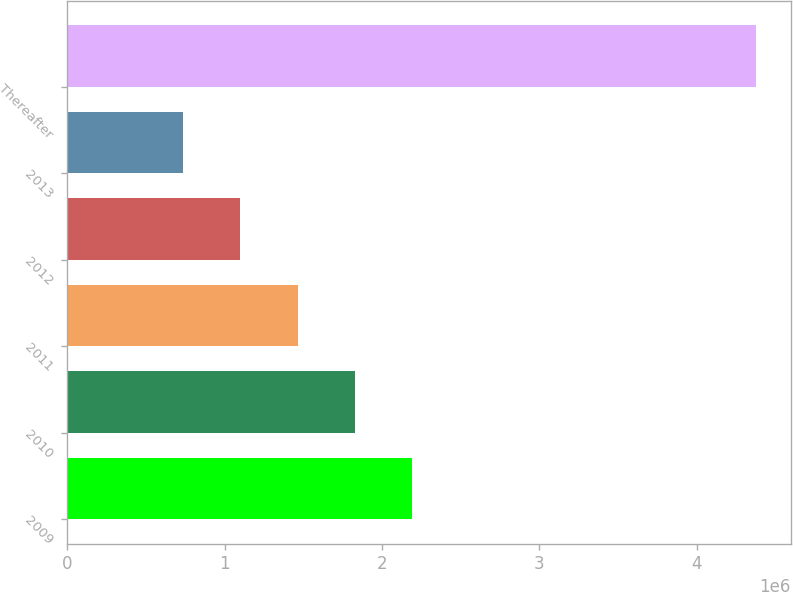Convert chart to OTSL. <chart><loc_0><loc_0><loc_500><loc_500><bar_chart><fcel>2009<fcel>2010<fcel>2011<fcel>2012<fcel>2013<fcel>Thereafter<nl><fcel>2.19232e+06<fcel>1.82804e+06<fcel>1.46377e+06<fcel>1.0995e+06<fcel>735220<fcel>4.37797e+06<nl></chart> 